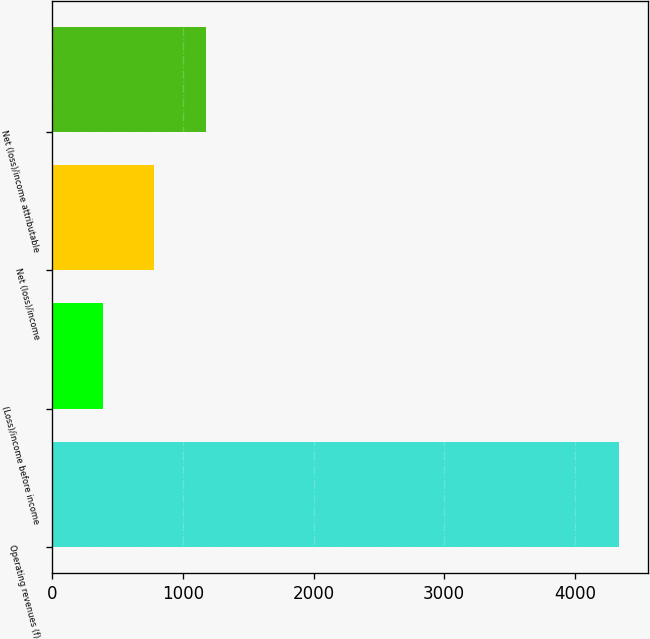<chart> <loc_0><loc_0><loc_500><loc_500><bar_chart><fcel>Operating revenues (f)<fcel>(Loss)/income before income<fcel>Net (loss)/income<fcel>Net (loss)/income attributable<nl><fcel>4341<fcel>384<fcel>779.7<fcel>1175.4<nl></chart> 